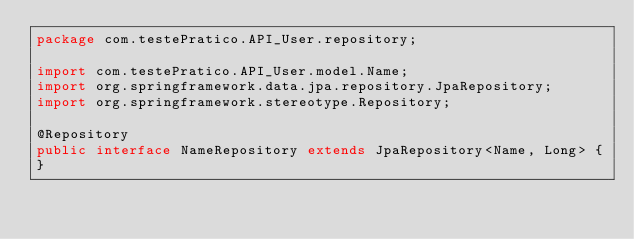Convert code to text. <code><loc_0><loc_0><loc_500><loc_500><_Java_>package com.testePratico.API_User.repository;

import com.testePratico.API_User.model.Name;
import org.springframework.data.jpa.repository.JpaRepository;
import org.springframework.stereotype.Repository;

@Repository
public interface NameRepository extends JpaRepository<Name, Long> {
}
</code> 